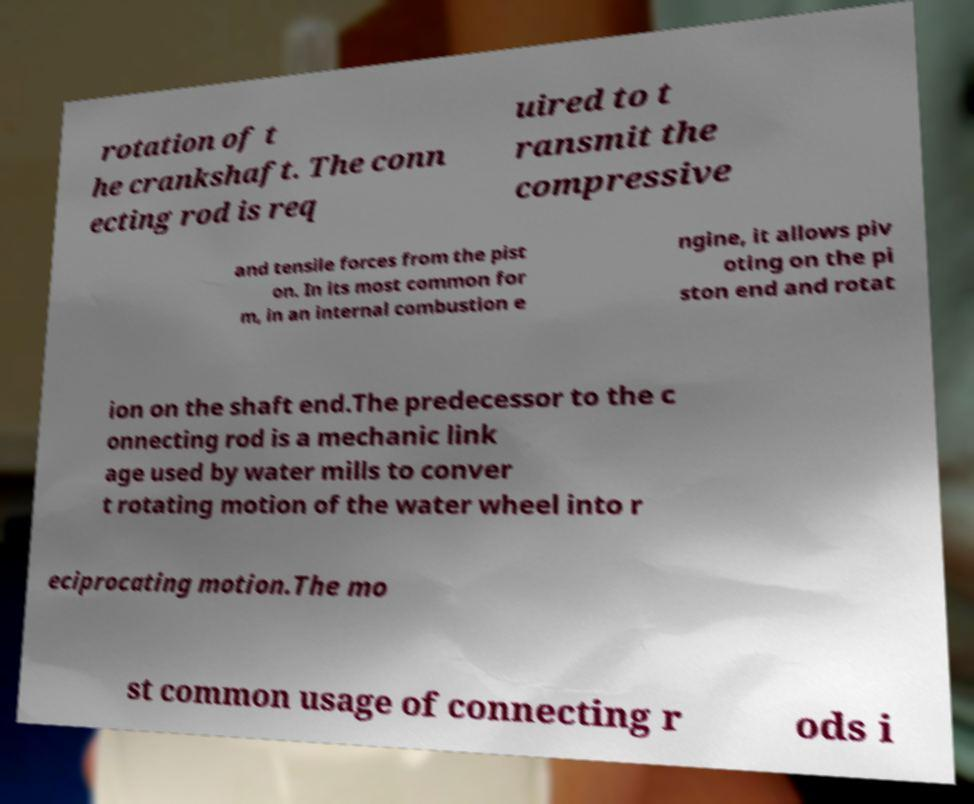There's text embedded in this image that I need extracted. Can you transcribe it verbatim? rotation of t he crankshaft. The conn ecting rod is req uired to t ransmit the compressive and tensile forces from the pist on. In its most common for m, in an internal combustion e ngine, it allows piv oting on the pi ston end and rotat ion on the shaft end.The predecessor to the c onnecting rod is a mechanic link age used by water mills to conver t rotating motion of the water wheel into r eciprocating motion.The mo st common usage of connecting r ods i 